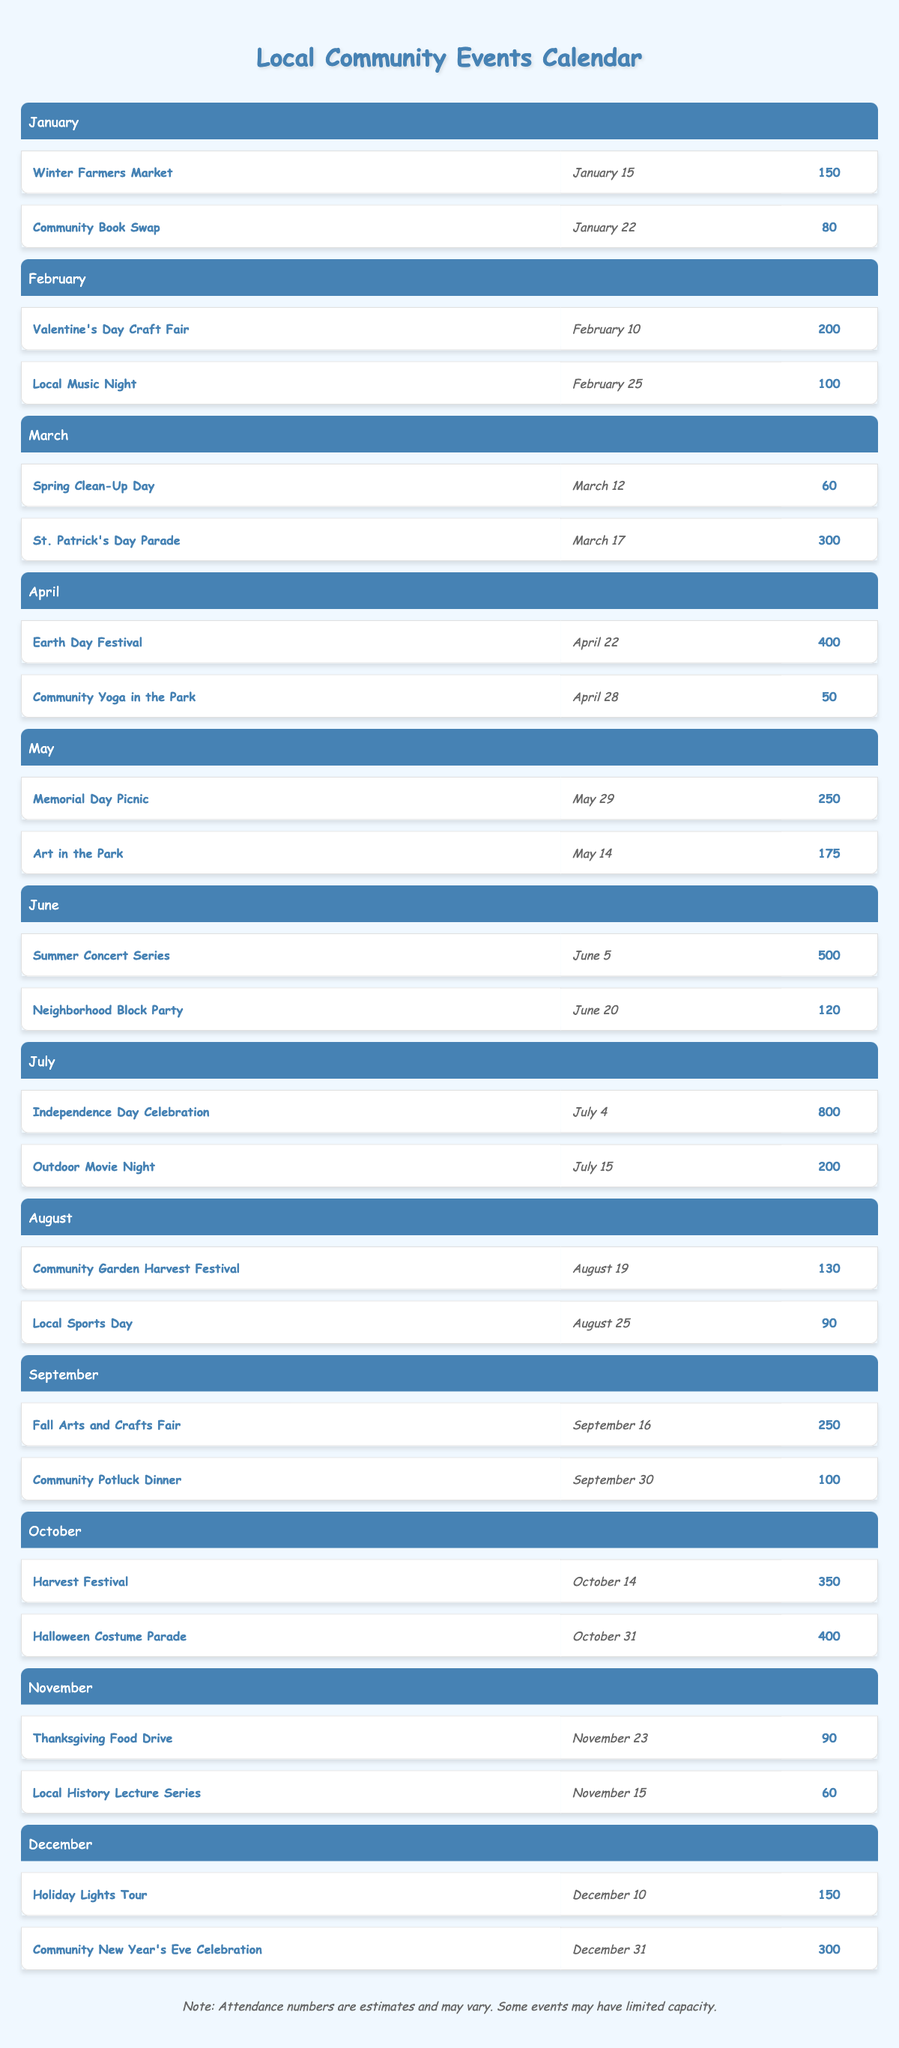What was the attendance for the Halloween Costume Parade? The event "Halloween Costume Parade" is listed under October. Looking at its attendance value, it shows 400.
Answer: 400 Which month had the highest attendance for any event? By examining the attendance figures for each event across months, "Independence Day Celebration" in July had the highest attendance of 800.
Answer: July What is the total attendance for events in April? The events in April are "Earth Day Festival" with an attendance of 400 and "Community Yoga in the Park" with an attendance of 50. To find the total, add these two values: 400 + 50 = 450.
Answer: 450 Did any event have an attendance of more than 600? By assessing the attendance numbers from the events listed, only "Independence Day Celebration" in July with an attendance of 800 exceeds 600. Therefore, the answer is yes.
Answer: Yes How many events had an attendance of less than 100? In reviewing the table, the events with attendance less than 100 are "Community Book Swap" (80), "Spring Clean-Up Day" (60), "Local Sports Day" (90), "Thanksgiving Food Drive" (90), and "Local History Lecture Series" (60). Counting these gives a total of 5 events.
Answer: 5 What is the average attendance for events in June? June has two events: "Summer Concert Series" with an attendance of 500 and "Neighborhood Block Party" with an attendance of 120. To calculate the average, sum the attendances: 500 + 120 = 620, then divide by the number of events, which is 2: 620 / 2 = 310.
Answer: 310 Which community event had the lowest attendance? By scanning through the attendance numbers listed for each event, "Community Yoga in the Park" in April has the lowest attendance of 50.
Answer: 50 How many events in July had an attendance of over 200? In July, the events listed are "Independence Day Celebration" with 800 and "Outdoor Movie Night" with 200. We only count "Independence Day Celebration" as it is the only one over 200. Thus, there is 1 event.
Answer: 1 